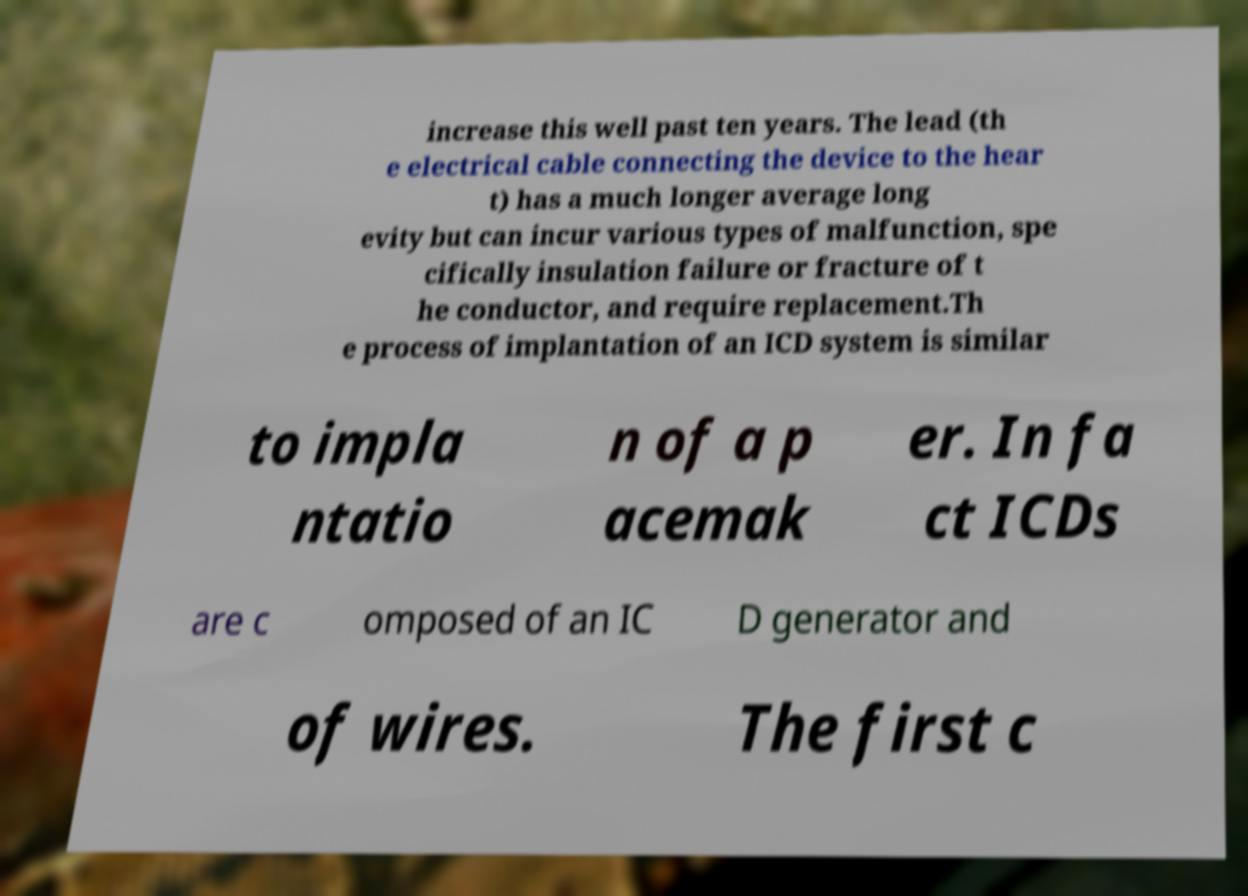There's text embedded in this image that I need extracted. Can you transcribe it verbatim? increase this well past ten years. The lead (th e electrical cable connecting the device to the hear t) has a much longer average long evity but can incur various types of malfunction, spe cifically insulation failure or fracture of t he conductor, and require replacement.Th e process of implantation of an ICD system is similar to impla ntatio n of a p acemak er. In fa ct ICDs are c omposed of an IC D generator and of wires. The first c 